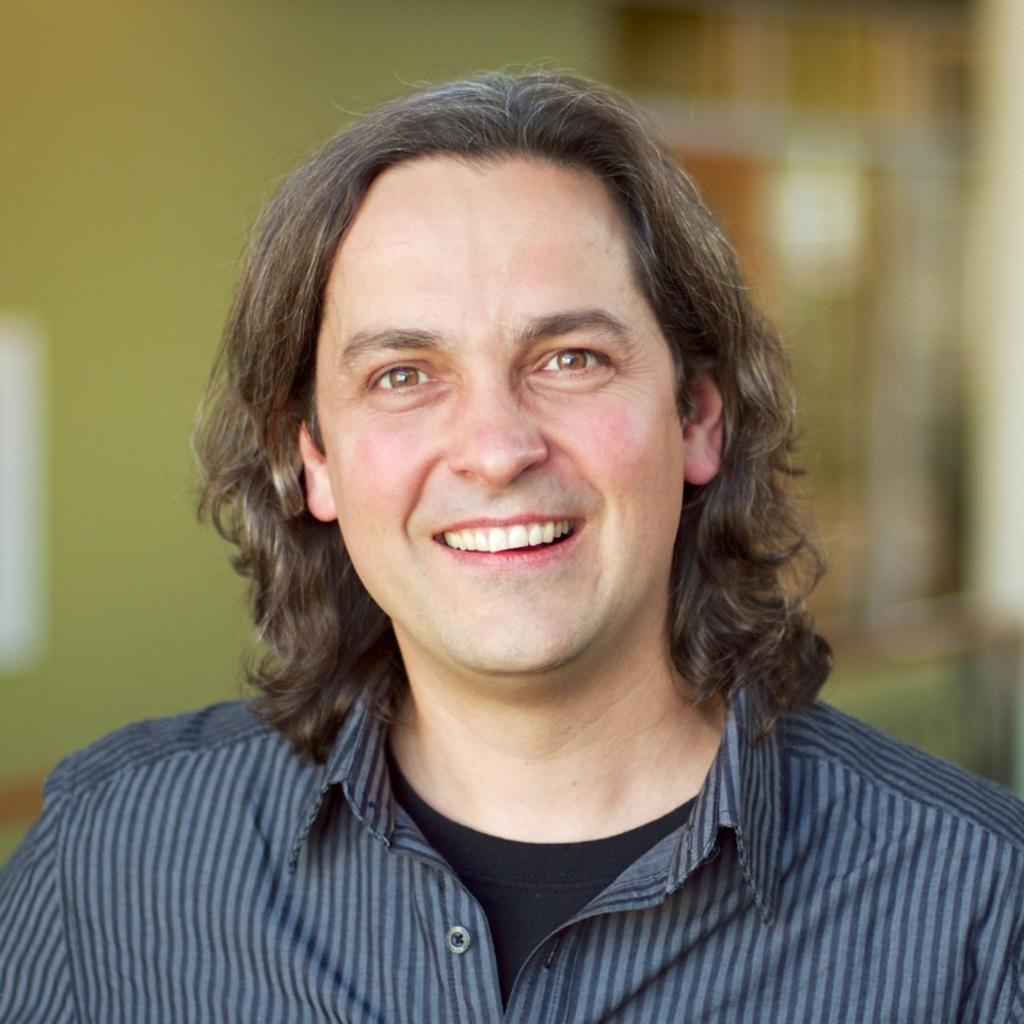Can you describe this image briefly? In this picture we can see a man is smiling and behind the man there is a blurred background. 